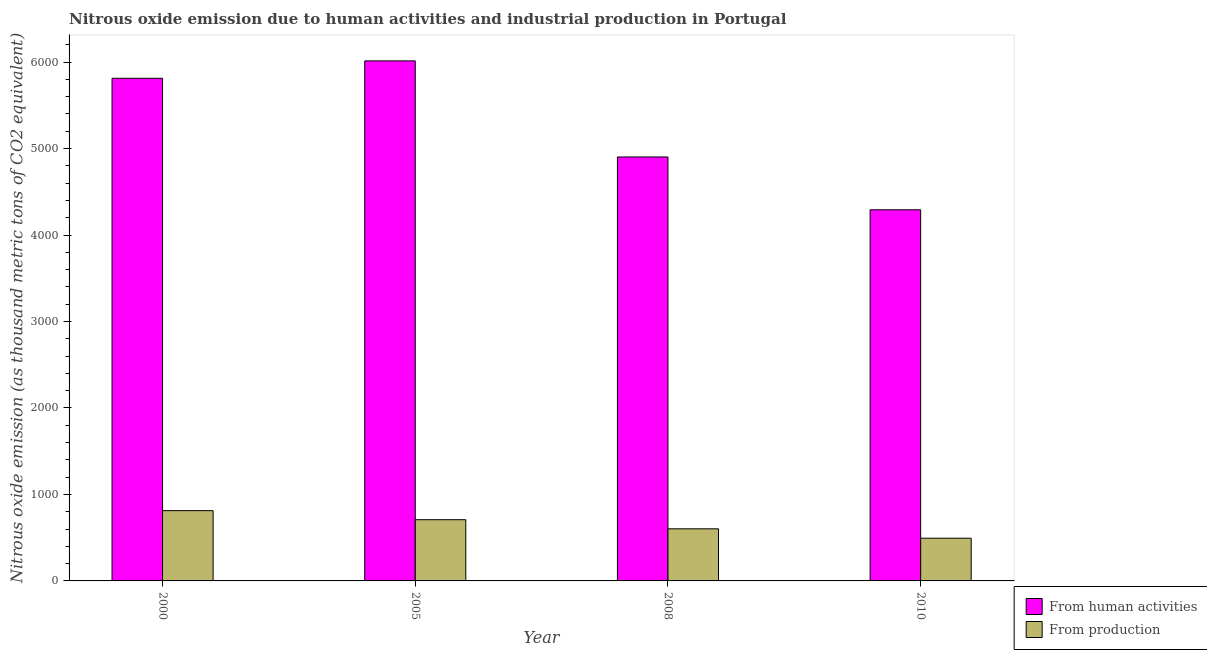How many different coloured bars are there?
Keep it short and to the point. 2. What is the amount of emissions generated from industries in 2000?
Your answer should be very brief. 812.7. Across all years, what is the maximum amount of emissions from human activities?
Provide a short and direct response. 6014.2. Across all years, what is the minimum amount of emissions from human activities?
Provide a short and direct response. 4291.9. In which year was the amount of emissions generated from industries minimum?
Offer a terse response. 2010. What is the total amount of emissions generated from industries in the graph?
Offer a very short reply. 2617.2. What is the difference between the amount of emissions generated from industries in 2000 and that in 2008?
Give a very brief answer. 210.2. What is the difference between the amount of emissions from human activities in 2005 and the amount of emissions generated from industries in 2008?
Offer a terse response. 1111.4. What is the average amount of emissions from human activities per year?
Give a very brief answer. 5255.38. In the year 2010, what is the difference between the amount of emissions generated from industries and amount of emissions from human activities?
Keep it short and to the point. 0. What is the ratio of the amount of emissions generated from industries in 2005 to that in 2008?
Offer a very short reply. 1.18. Is the difference between the amount of emissions generated from industries in 2005 and 2008 greater than the difference between the amount of emissions from human activities in 2005 and 2008?
Your response must be concise. No. What is the difference between the highest and the second highest amount of emissions from human activities?
Offer a very short reply. 201.6. What is the difference between the highest and the lowest amount of emissions from human activities?
Ensure brevity in your answer.  1722.3. In how many years, is the amount of emissions generated from industries greater than the average amount of emissions generated from industries taken over all years?
Ensure brevity in your answer.  2. What does the 2nd bar from the left in 2005 represents?
Offer a very short reply. From production. What does the 2nd bar from the right in 2008 represents?
Keep it short and to the point. From human activities. Are all the bars in the graph horizontal?
Your answer should be very brief. No. How many years are there in the graph?
Give a very brief answer. 4. What is the title of the graph?
Provide a succinct answer. Nitrous oxide emission due to human activities and industrial production in Portugal. Does "Infant" appear as one of the legend labels in the graph?
Your answer should be compact. No. What is the label or title of the X-axis?
Your answer should be very brief. Year. What is the label or title of the Y-axis?
Your answer should be compact. Nitrous oxide emission (as thousand metric tons of CO2 equivalent). What is the Nitrous oxide emission (as thousand metric tons of CO2 equivalent) in From human activities in 2000?
Provide a short and direct response. 5812.6. What is the Nitrous oxide emission (as thousand metric tons of CO2 equivalent) of From production in 2000?
Provide a succinct answer. 812.7. What is the Nitrous oxide emission (as thousand metric tons of CO2 equivalent) in From human activities in 2005?
Make the answer very short. 6014.2. What is the Nitrous oxide emission (as thousand metric tons of CO2 equivalent) of From production in 2005?
Ensure brevity in your answer.  708. What is the Nitrous oxide emission (as thousand metric tons of CO2 equivalent) in From human activities in 2008?
Make the answer very short. 4902.8. What is the Nitrous oxide emission (as thousand metric tons of CO2 equivalent) of From production in 2008?
Provide a succinct answer. 602.5. What is the Nitrous oxide emission (as thousand metric tons of CO2 equivalent) of From human activities in 2010?
Make the answer very short. 4291.9. What is the Nitrous oxide emission (as thousand metric tons of CO2 equivalent) of From production in 2010?
Keep it short and to the point. 494. Across all years, what is the maximum Nitrous oxide emission (as thousand metric tons of CO2 equivalent) in From human activities?
Offer a very short reply. 6014.2. Across all years, what is the maximum Nitrous oxide emission (as thousand metric tons of CO2 equivalent) in From production?
Your response must be concise. 812.7. Across all years, what is the minimum Nitrous oxide emission (as thousand metric tons of CO2 equivalent) in From human activities?
Offer a very short reply. 4291.9. Across all years, what is the minimum Nitrous oxide emission (as thousand metric tons of CO2 equivalent) in From production?
Your response must be concise. 494. What is the total Nitrous oxide emission (as thousand metric tons of CO2 equivalent) of From human activities in the graph?
Your response must be concise. 2.10e+04. What is the total Nitrous oxide emission (as thousand metric tons of CO2 equivalent) in From production in the graph?
Make the answer very short. 2617.2. What is the difference between the Nitrous oxide emission (as thousand metric tons of CO2 equivalent) of From human activities in 2000 and that in 2005?
Ensure brevity in your answer.  -201.6. What is the difference between the Nitrous oxide emission (as thousand metric tons of CO2 equivalent) of From production in 2000 and that in 2005?
Offer a very short reply. 104.7. What is the difference between the Nitrous oxide emission (as thousand metric tons of CO2 equivalent) of From human activities in 2000 and that in 2008?
Ensure brevity in your answer.  909.8. What is the difference between the Nitrous oxide emission (as thousand metric tons of CO2 equivalent) in From production in 2000 and that in 2008?
Provide a succinct answer. 210.2. What is the difference between the Nitrous oxide emission (as thousand metric tons of CO2 equivalent) of From human activities in 2000 and that in 2010?
Ensure brevity in your answer.  1520.7. What is the difference between the Nitrous oxide emission (as thousand metric tons of CO2 equivalent) of From production in 2000 and that in 2010?
Provide a short and direct response. 318.7. What is the difference between the Nitrous oxide emission (as thousand metric tons of CO2 equivalent) in From human activities in 2005 and that in 2008?
Your answer should be compact. 1111.4. What is the difference between the Nitrous oxide emission (as thousand metric tons of CO2 equivalent) of From production in 2005 and that in 2008?
Offer a terse response. 105.5. What is the difference between the Nitrous oxide emission (as thousand metric tons of CO2 equivalent) in From human activities in 2005 and that in 2010?
Make the answer very short. 1722.3. What is the difference between the Nitrous oxide emission (as thousand metric tons of CO2 equivalent) of From production in 2005 and that in 2010?
Provide a short and direct response. 214. What is the difference between the Nitrous oxide emission (as thousand metric tons of CO2 equivalent) of From human activities in 2008 and that in 2010?
Your answer should be very brief. 610.9. What is the difference between the Nitrous oxide emission (as thousand metric tons of CO2 equivalent) in From production in 2008 and that in 2010?
Give a very brief answer. 108.5. What is the difference between the Nitrous oxide emission (as thousand metric tons of CO2 equivalent) in From human activities in 2000 and the Nitrous oxide emission (as thousand metric tons of CO2 equivalent) in From production in 2005?
Provide a succinct answer. 5104.6. What is the difference between the Nitrous oxide emission (as thousand metric tons of CO2 equivalent) in From human activities in 2000 and the Nitrous oxide emission (as thousand metric tons of CO2 equivalent) in From production in 2008?
Offer a very short reply. 5210.1. What is the difference between the Nitrous oxide emission (as thousand metric tons of CO2 equivalent) of From human activities in 2000 and the Nitrous oxide emission (as thousand metric tons of CO2 equivalent) of From production in 2010?
Provide a succinct answer. 5318.6. What is the difference between the Nitrous oxide emission (as thousand metric tons of CO2 equivalent) in From human activities in 2005 and the Nitrous oxide emission (as thousand metric tons of CO2 equivalent) in From production in 2008?
Offer a very short reply. 5411.7. What is the difference between the Nitrous oxide emission (as thousand metric tons of CO2 equivalent) of From human activities in 2005 and the Nitrous oxide emission (as thousand metric tons of CO2 equivalent) of From production in 2010?
Provide a succinct answer. 5520.2. What is the difference between the Nitrous oxide emission (as thousand metric tons of CO2 equivalent) in From human activities in 2008 and the Nitrous oxide emission (as thousand metric tons of CO2 equivalent) in From production in 2010?
Offer a very short reply. 4408.8. What is the average Nitrous oxide emission (as thousand metric tons of CO2 equivalent) of From human activities per year?
Give a very brief answer. 5255.38. What is the average Nitrous oxide emission (as thousand metric tons of CO2 equivalent) in From production per year?
Offer a terse response. 654.3. In the year 2000, what is the difference between the Nitrous oxide emission (as thousand metric tons of CO2 equivalent) in From human activities and Nitrous oxide emission (as thousand metric tons of CO2 equivalent) in From production?
Your answer should be very brief. 4999.9. In the year 2005, what is the difference between the Nitrous oxide emission (as thousand metric tons of CO2 equivalent) in From human activities and Nitrous oxide emission (as thousand metric tons of CO2 equivalent) in From production?
Offer a very short reply. 5306.2. In the year 2008, what is the difference between the Nitrous oxide emission (as thousand metric tons of CO2 equivalent) in From human activities and Nitrous oxide emission (as thousand metric tons of CO2 equivalent) in From production?
Keep it short and to the point. 4300.3. In the year 2010, what is the difference between the Nitrous oxide emission (as thousand metric tons of CO2 equivalent) in From human activities and Nitrous oxide emission (as thousand metric tons of CO2 equivalent) in From production?
Give a very brief answer. 3797.9. What is the ratio of the Nitrous oxide emission (as thousand metric tons of CO2 equivalent) in From human activities in 2000 to that in 2005?
Offer a terse response. 0.97. What is the ratio of the Nitrous oxide emission (as thousand metric tons of CO2 equivalent) in From production in 2000 to that in 2005?
Your response must be concise. 1.15. What is the ratio of the Nitrous oxide emission (as thousand metric tons of CO2 equivalent) in From human activities in 2000 to that in 2008?
Ensure brevity in your answer.  1.19. What is the ratio of the Nitrous oxide emission (as thousand metric tons of CO2 equivalent) in From production in 2000 to that in 2008?
Make the answer very short. 1.35. What is the ratio of the Nitrous oxide emission (as thousand metric tons of CO2 equivalent) in From human activities in 2000 to that in 2010?
Your response must be concise. 1.35. What is the ratio of the Nitrous oxide emission (as thousand metric tons of CO2 equivalent) of From production in 2000 to that in 2010?
Provide a succinct answer. 1.65. What is the ratio of the Nitrous oxide emission (as thousand metric tons of CO2 equivalent) of From human activities in 2005 to that in 2008?
Your answer should be compact. 1.23. What is the ratio of the Nitrous oxide emission (as thousand metric tons of CO2 equivalent) of From production in 2005 to that in 2008?
Offer a terse response. 1.18. What is the ratio of the Nitrous oxide emission (as thousand metric tons of CO2 equivalent) of From human activities in 2005 to that in 2010?
Ensure brevity in your answer.  1.4. What is the ratio of the Nitrous oxide emission (as thousand metric tons of CO2 equivalent) of From production in 2005 to that in 2010?
Provide a short and direct response. 1.43. What is the ratio of the Nitrous oxide emission (as thousand metric tons of CO2 equivalent) in From human activities in 2008 to that in 2010?
Offer a very short reply. 1.14. What is the ratio of the Nitrous oxide emission (as thousand metric tons of CO2 equivalent) in From production in 2008 to that in 2010?
Your answer should be very brief. 1.22. What is the difference between the highest and the second highest Nitrous oxide emission (as thousand metric tons of CO2 equivalent) of From human activities?
Provide a succinct answer. 201.6. What is the difference between the highest and the second highest Nitrous oxide emission (as thousand metric tons of CO2 equivalent) of From production?
Keep it short and to the point. 104.7. What is the difference between the highest and the lowest Nitrous oxide emission (as thousand metric tons of CO2 equivalent) of From human activities?
Your response must be concise. 1722.3. What is the difference between the highest and the lowest Nitrous oxide emission (as thousand metric tons of CO2 equivalent) in From production?
Offer a terse response. 318.7. 